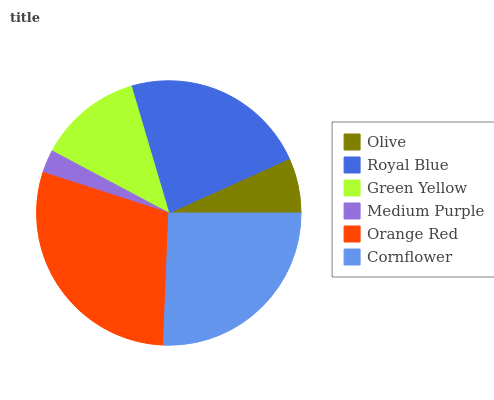Is Medium Purple the minimum?
Answer yes or no. Yes. Is Orange Red the maximum?
Answer yes or no. Yes. Is Royal Blue the minimum?
Answer yes or no. No. Is Royal Blue the maximum?
Answer yes or no. No. Is Royal Blue greater than Olive?
Answer yes or no. Yes. Is Olive less than Royal Blue?
Answer yes or no. Yes. Is Olive greater than Royal Blue?
Answer yes or no. No. Is Royal Blue less than Olive?
Answer yes or no. No. Is Royal Blue the high median?
Answer yes or no. Yes. Is Green Yellow the low median?
Answer yes or no. Yes. Is Medium Purple the high median?
Answer yes or no. No. Is Orange Red the low median?
Answer yes or no. No. 